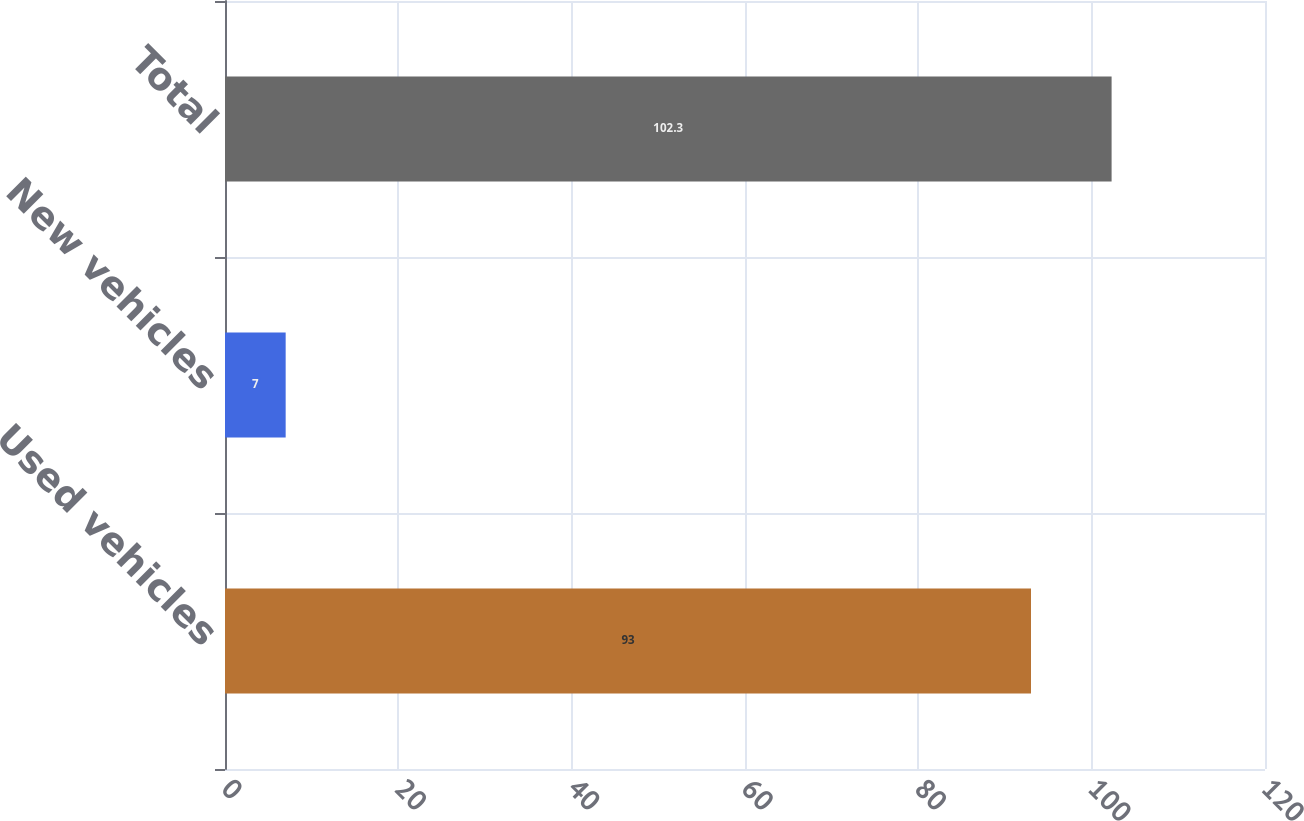Convert chart. <chart><loc_0><loc_0><loc_500><loc_500><bar_chart><fcel>Used vehicles<fcel>New vehicles<fcel>Total<nl><fcel>93<fcel>7<fcel>102.3<nl></chart> 